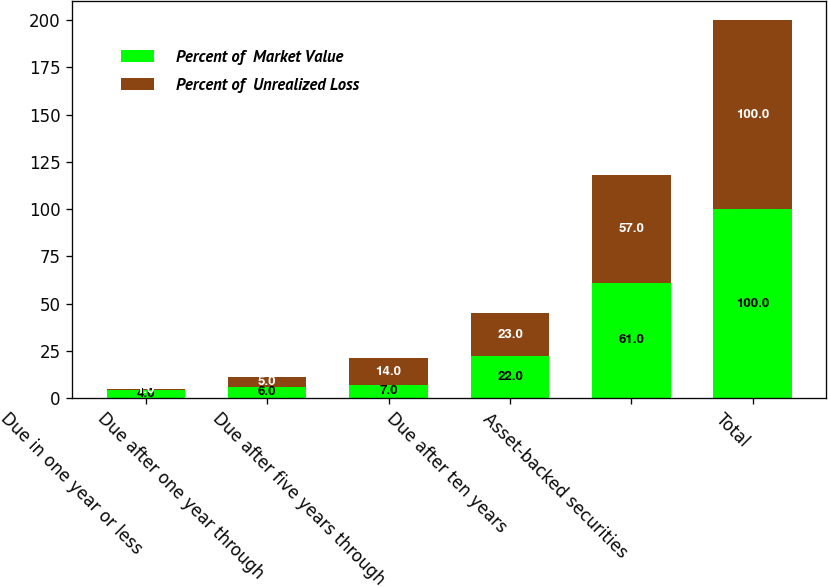Convert chart. <chart><loc_0><loc_0><loc_500><loc_500><stacked_bar_chart><ecel><fcel>Due in one year or less<fcel>Due after one year through<fcel>Due after five years through<fcel>Due after ten years<fcel>Asset-backed securities<fcel>Total<nl><fcel>Percent of  Market Value<fcel>4<fcel>6<fcel>7<fcel>22<fcel>61<fcel>100<nl><fcel>Percent of  Unrealized Loss<fcel>1<fcel>5<fcel>14<fcel>23<fcel>57<fcel>100<nl></chart> 